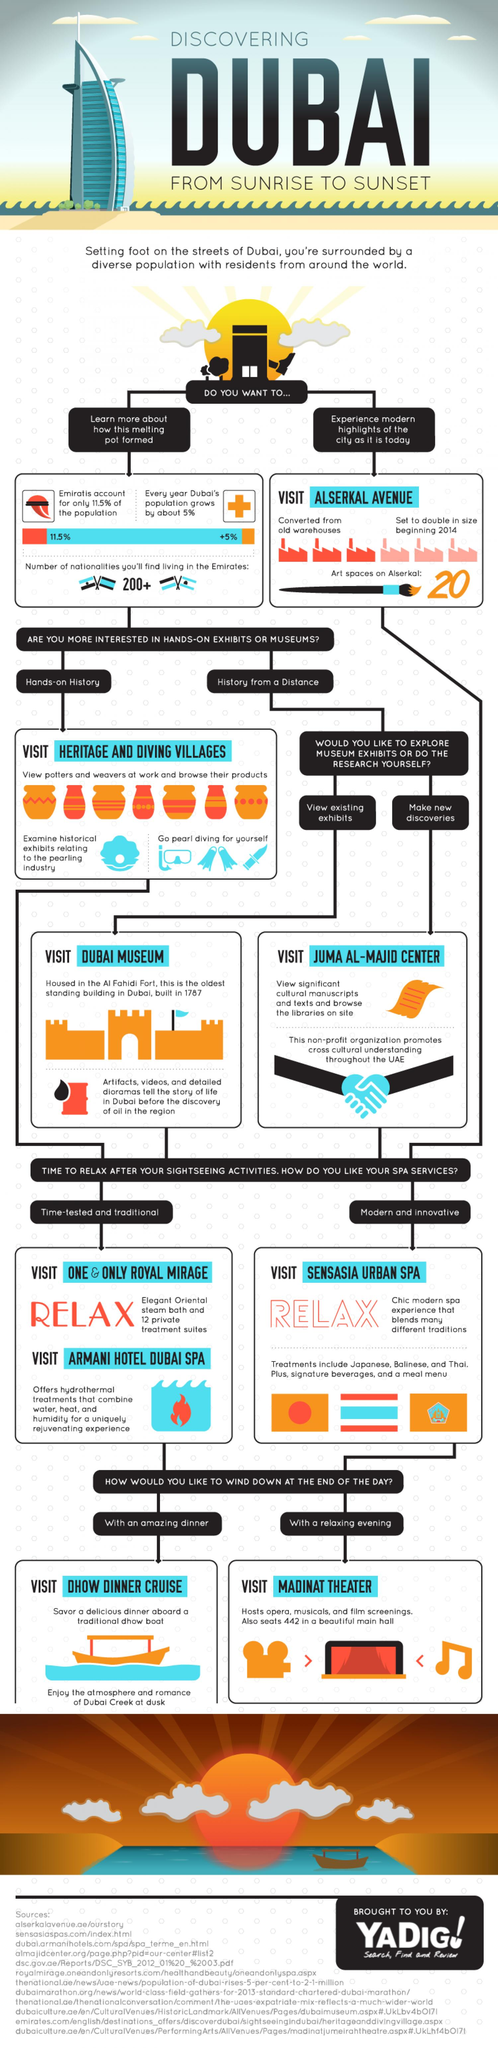Outline some significant characteristics in this image. Dubai Museum is the best place to visit in Dubai for those interested in viewing exhibits. There are two distinct types of spa services: time-tested and traditional, and modern and innovative. Sensasia Urban Spa is a modern and innovative spa located in Dubai. The Dhow Dinner Cruise is a dinner space located in Dubai. Dubai offers a variety of historical places to visit, including heritage and diving villages, that provide hands-on experiences for those interested in history. 